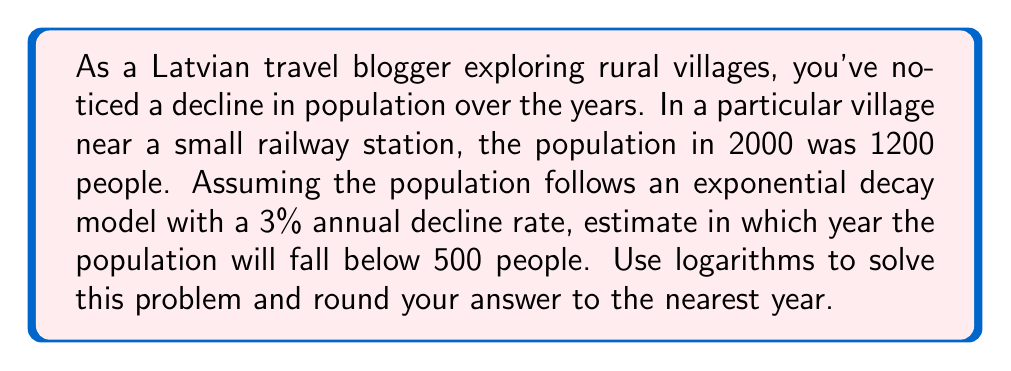Solve this math problem. Let's approach this step-by-step using the exponential decay formula and logarithms:

1) The exponential decay formula is:
   $$P(t) = P_0 \cdot e^{-rt}$$
   Where:
   $P(t)$ is the population after $t$ years
   $P_0$ is the initial population
   $r$ is the decay rate
   $t$ is the time in years

2) We're given:
   $P_0 = 1200$ (initial population in 2000)
   $r = 0.03$ (3% annual decline)
   We want to find $t$ when $P(t) = 500$

3) Substituting into the formula:
   $$500 = 1200 \cdot e^{-0.03t}$$

4) Divide both sides by 1200:
   $$\frac{500}{1200} = e^{-0.03t}$$

5) Take the natural logarithm of both sides:
   $$\ln(\frac{500}{1200}) = \ln(e^{-0.03t})$$

6) Simplify the right side:
   $$\ln(\frac{500}{1200}) = -0.03t$$

7) Solve for $t$:
   $$t = \frac{\ln(\frac{500}{1200})}{-0.03}$$

8) Calculate:
   $$t = \frac{\ln(0.4167)}{-0.03} \approx 29.37$$

9) Round to the nearest year: 29 years

10) Since we started in 2000, add 29 to 2000:
    2000 + 29 = 2029

Therefore, the population will fall below 500 people in 2029.
Answer: 2029 